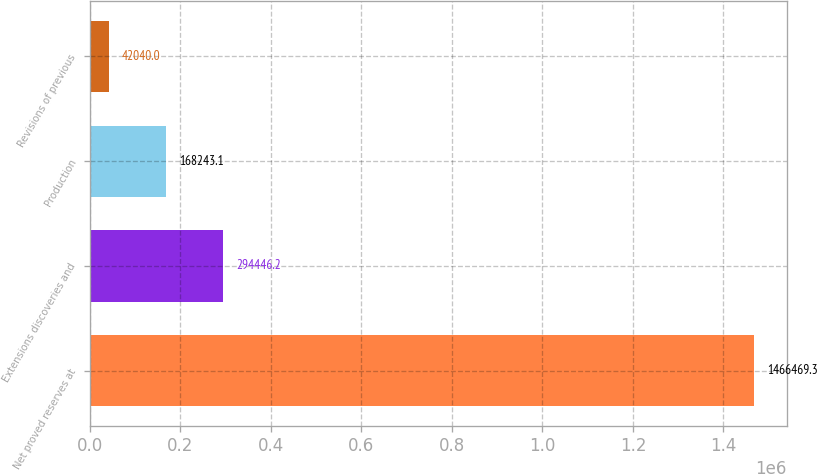Convert chart. <chart><loc_0><loc_0><loc_500><loc_500><bar_chart><fcel>Net proved reserves at<fcel>Extensions discoveries and<fcel>Production<fcel>Revisions of previous<nl><fcel>1.46647e+06<fcel>294446<fcel>168243<fcel>42040<nl></chart> 